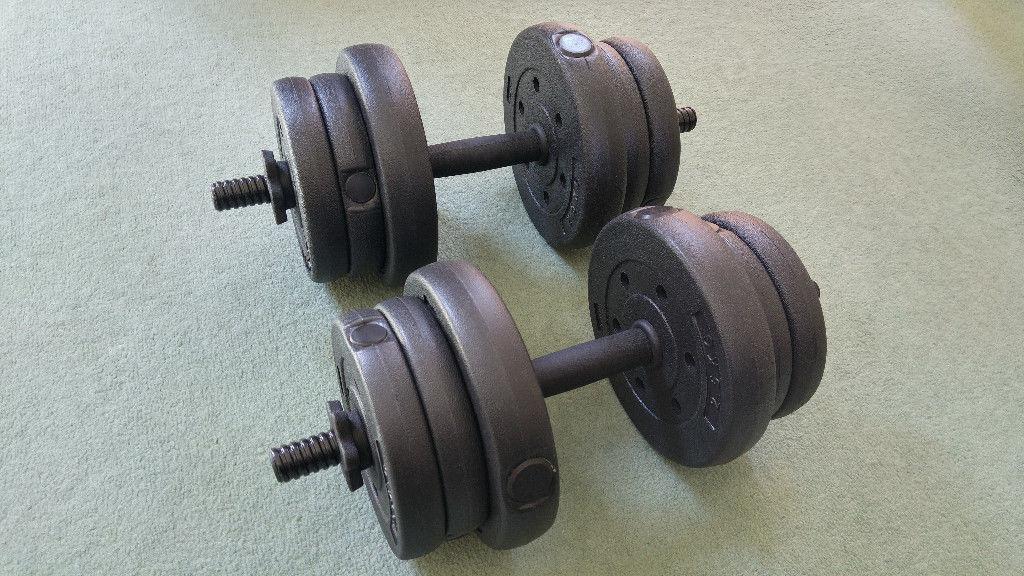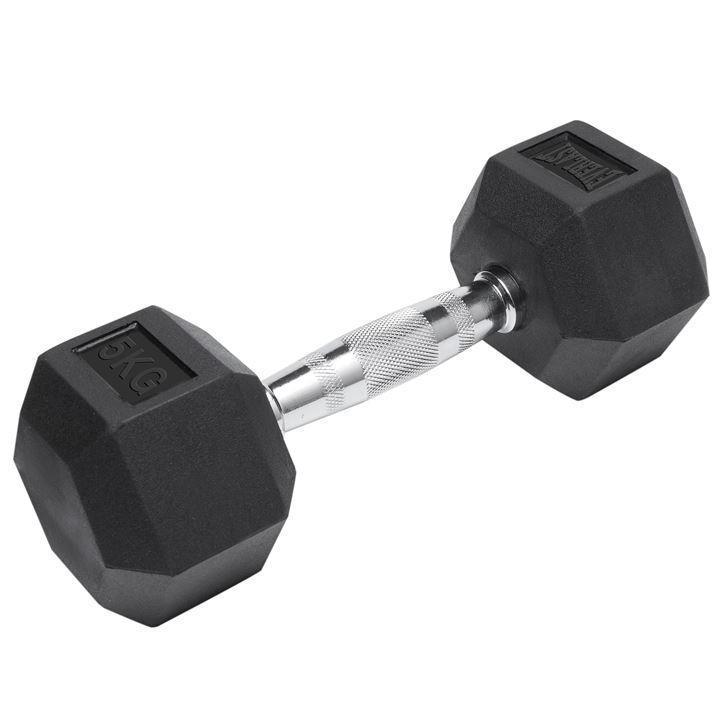The first image is the image on the left, the second image is the image on the right. Evaluate the accuracy of this statement regarding the images: "There are exactly three dumbbells.". Is it true? Answer yes or no. Yes. The first image is the image on the left, the second image is the image on the right. Analyze the images presented: Is the assertion "The left image contains two dumbells without pipe sticking out." valid? Answer yes or no. No. 